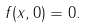Convert formula to latex. <formula><loc_0><loc_0><loc_500><loc_500>f ( x , 0 ) = 0 .</formula> 